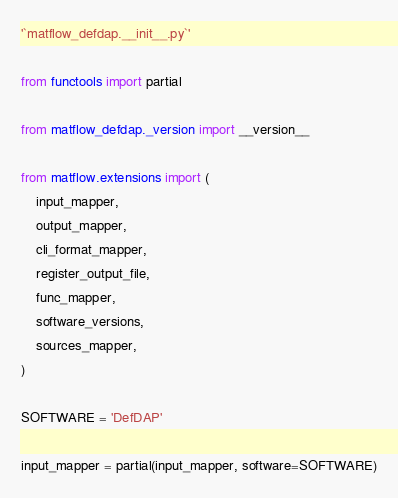<code> <loc_0><loc_0><loc_500><loc_500><_Python_>'`matflow_defdap.__init__.py`'

from functools import partial

from matflow_defdap._version import __version__

from matflow.extensions import (
    input_mapper,
    output_mapper,
    cli_format_mapper,
    register_output_file,
    func_mapper,
    software_versions,
    sources_mapper,
)

SOFTWARE = 'DefDAP'

input_mapper = partial(input_mapper, software=SOFTWARE)</code> 